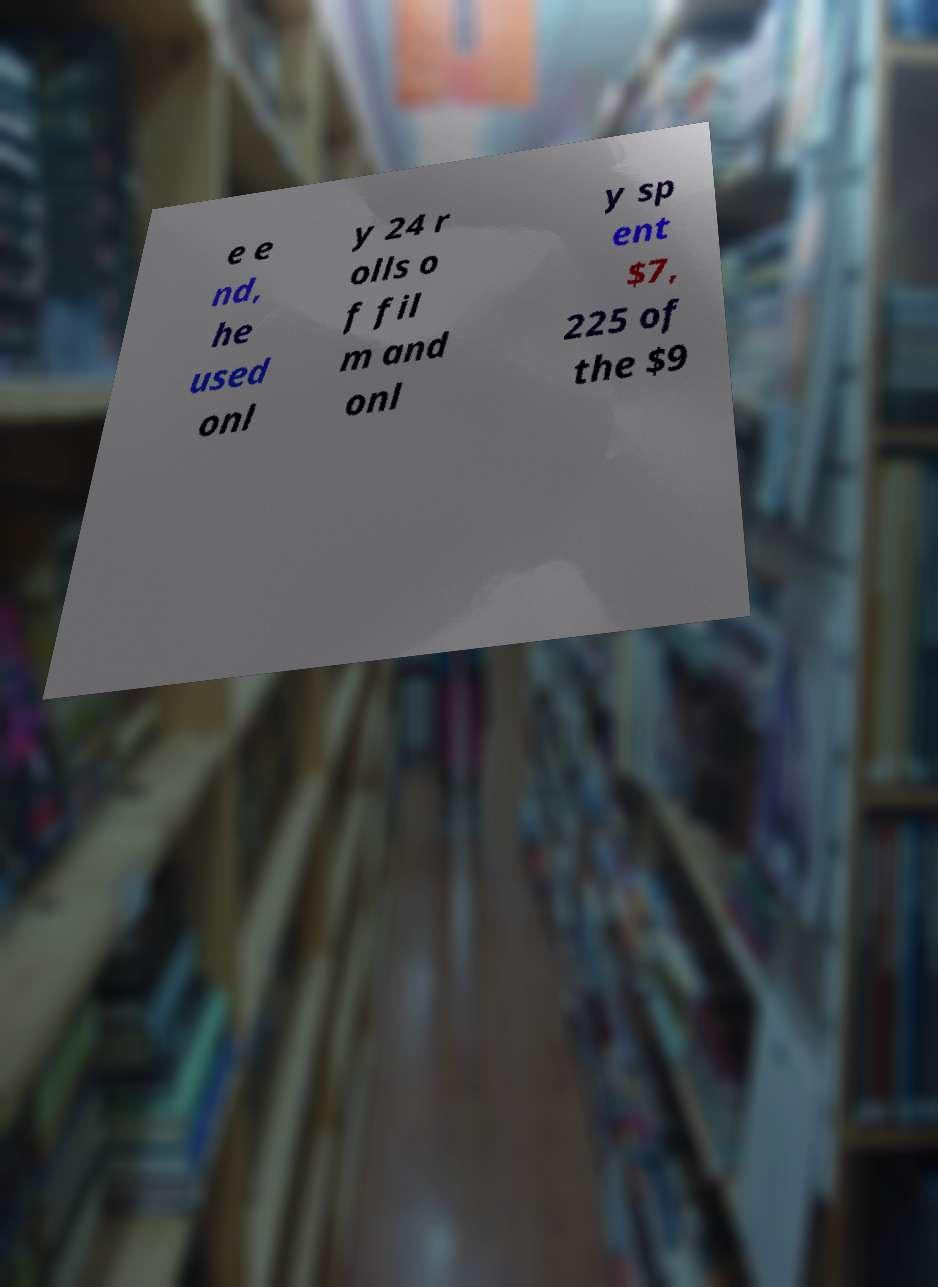For documentation purposes, I need the text within this image transcribed. Could you provide that? e e nd, he used onl y 24 r olls o f fil m and onl y sp ent $7, 225 of the $9 